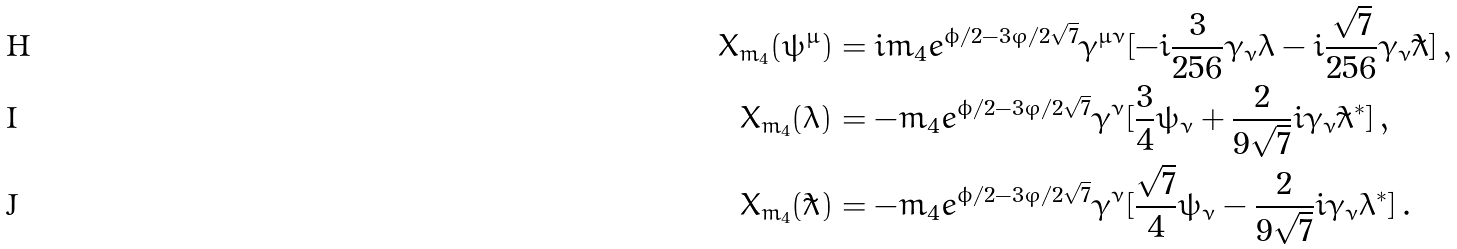Convert formula to latex. <formula><loc_0><loc_0><loc_500><loc_500>X _ { m _ { 4 } } ( \psi ^ { \mu } ) & = i m _ { 4 } e ^ { \phi / 2 - 3 \varphi / 2 \sqrt { 7 } } \gamma ^ { \mu \nu } [ - i \frac { 3 } { 2 5 6 } \gamma _ { \nu } \lambda - i \frac { \sqrt { 7 } } { 2 5 6 } \gamma _ { \nu } \tilde { \lambda } ] \, , \\ X _ { m _ { 4 } } ( \lambda ) & = - m _ { 4 } e ^ { \phi / 2 - 3 \varphi / 2 \sqrt { 7 } } \gamma ^ { \nu } [ \frac { 3 } { 4 } \psi _ { \nu } + \frac { 2 } { 9 \sqrt { 7 } } i \gamma _ { \nu } \tilde { \lambda } ^ { * } ] \, , \\ X _ { m _ { 4 } } ( \tilde { \lambda } ) & = - m _ { 4 } e ^ { \phi / 2 - 3 \varphi / 2 \sqrt { 7 } } \gamma ^ { \nu } [ \frac { \sqrt { 7 } } { 4 } \psi _ { \nu } - \frac { 2 } { 9 \sqrt { 7 } } i \gamma _ { \nu } \lambda ^ { * } ] \, .</formula> 